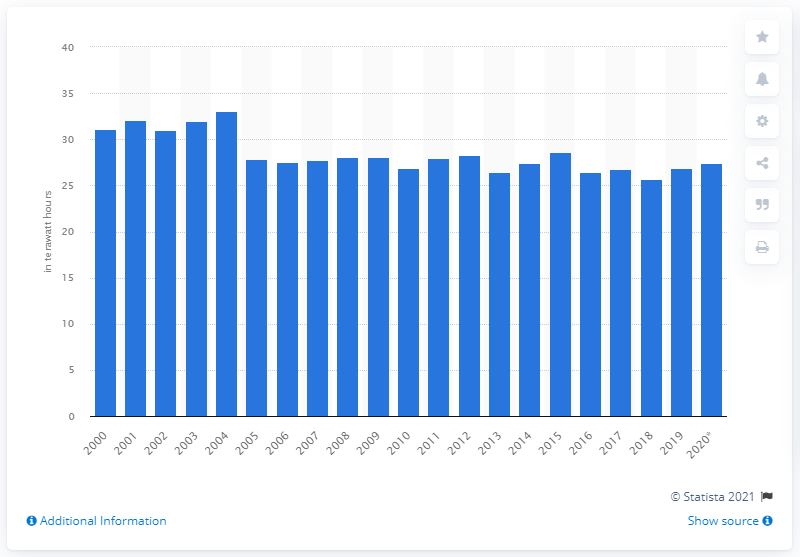Identify some key points in this picture. In 2004, 33.09 megawatt hours were lost. The peak of transmission and distribution losses occurred in the British public electricity system in the year 2004. 